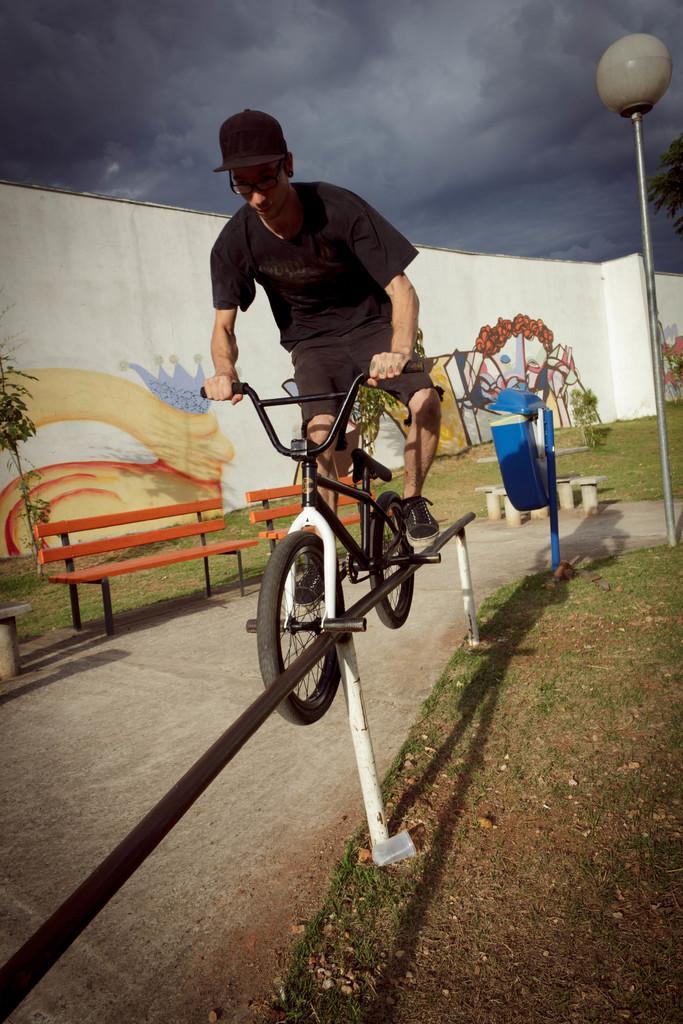Could you give a brief overview of what you see in this image? It is a road, on the either side of the road there is grass, to the left side there are two benches to the right side there is a rod a person is performing some feats on the rod , in the background there is a white color wall, a dustbin, sky covered with dark clouds. 